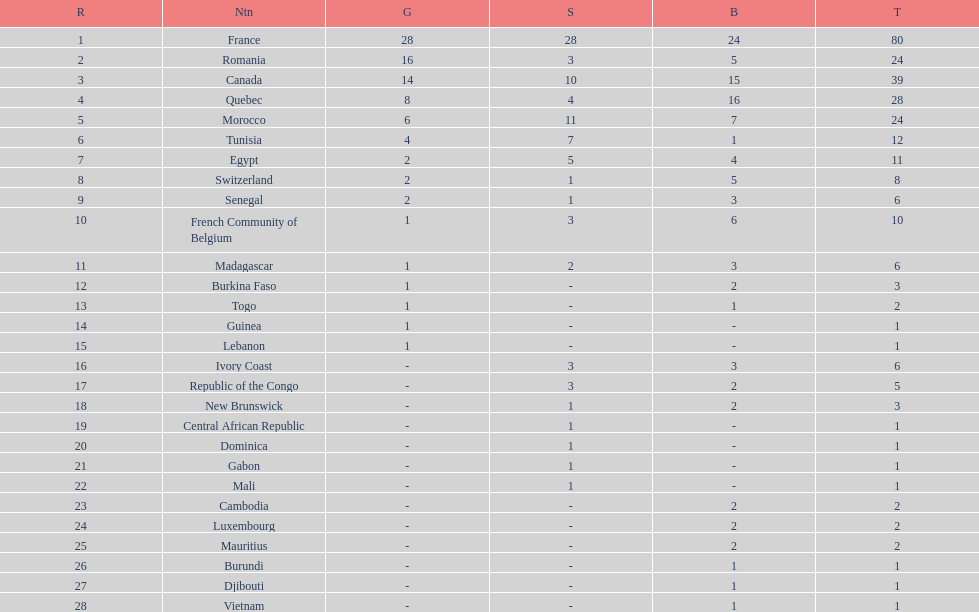Who placed in first according to medals? France. 